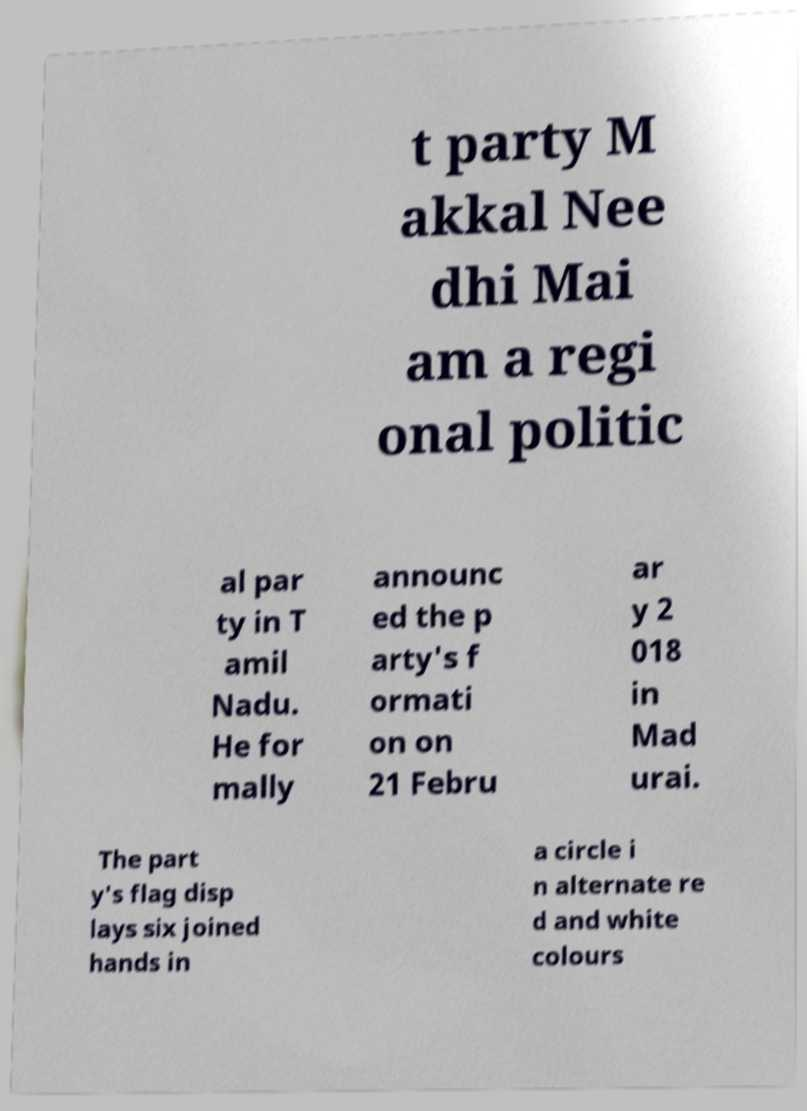Can you read and provide the text displayed in the image?This photo seems to have some interesting text. Can you extract and type it out for me? t party M akkal Nee dhi Mai am a regi onal politic al par ty in T amil Nadu. He for mally announc ed the p arty's f ormati on on 21 Febru ar y 2 018 in Mad urai. The part y's flag disp lays six joined hands in a circle i n alternate re d and white colours 